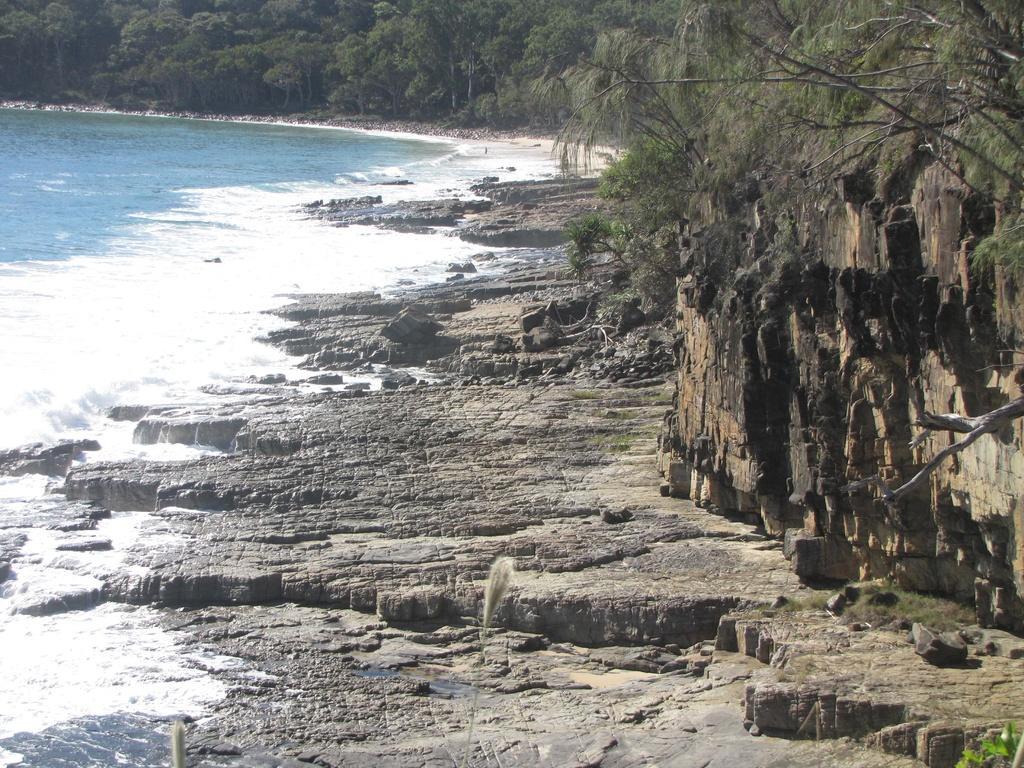In one or two sentences, can you explain what this image depicts? In this image on the left side there is water. On the right side there are stones on the ground and there are plants. In the background there are trees. 